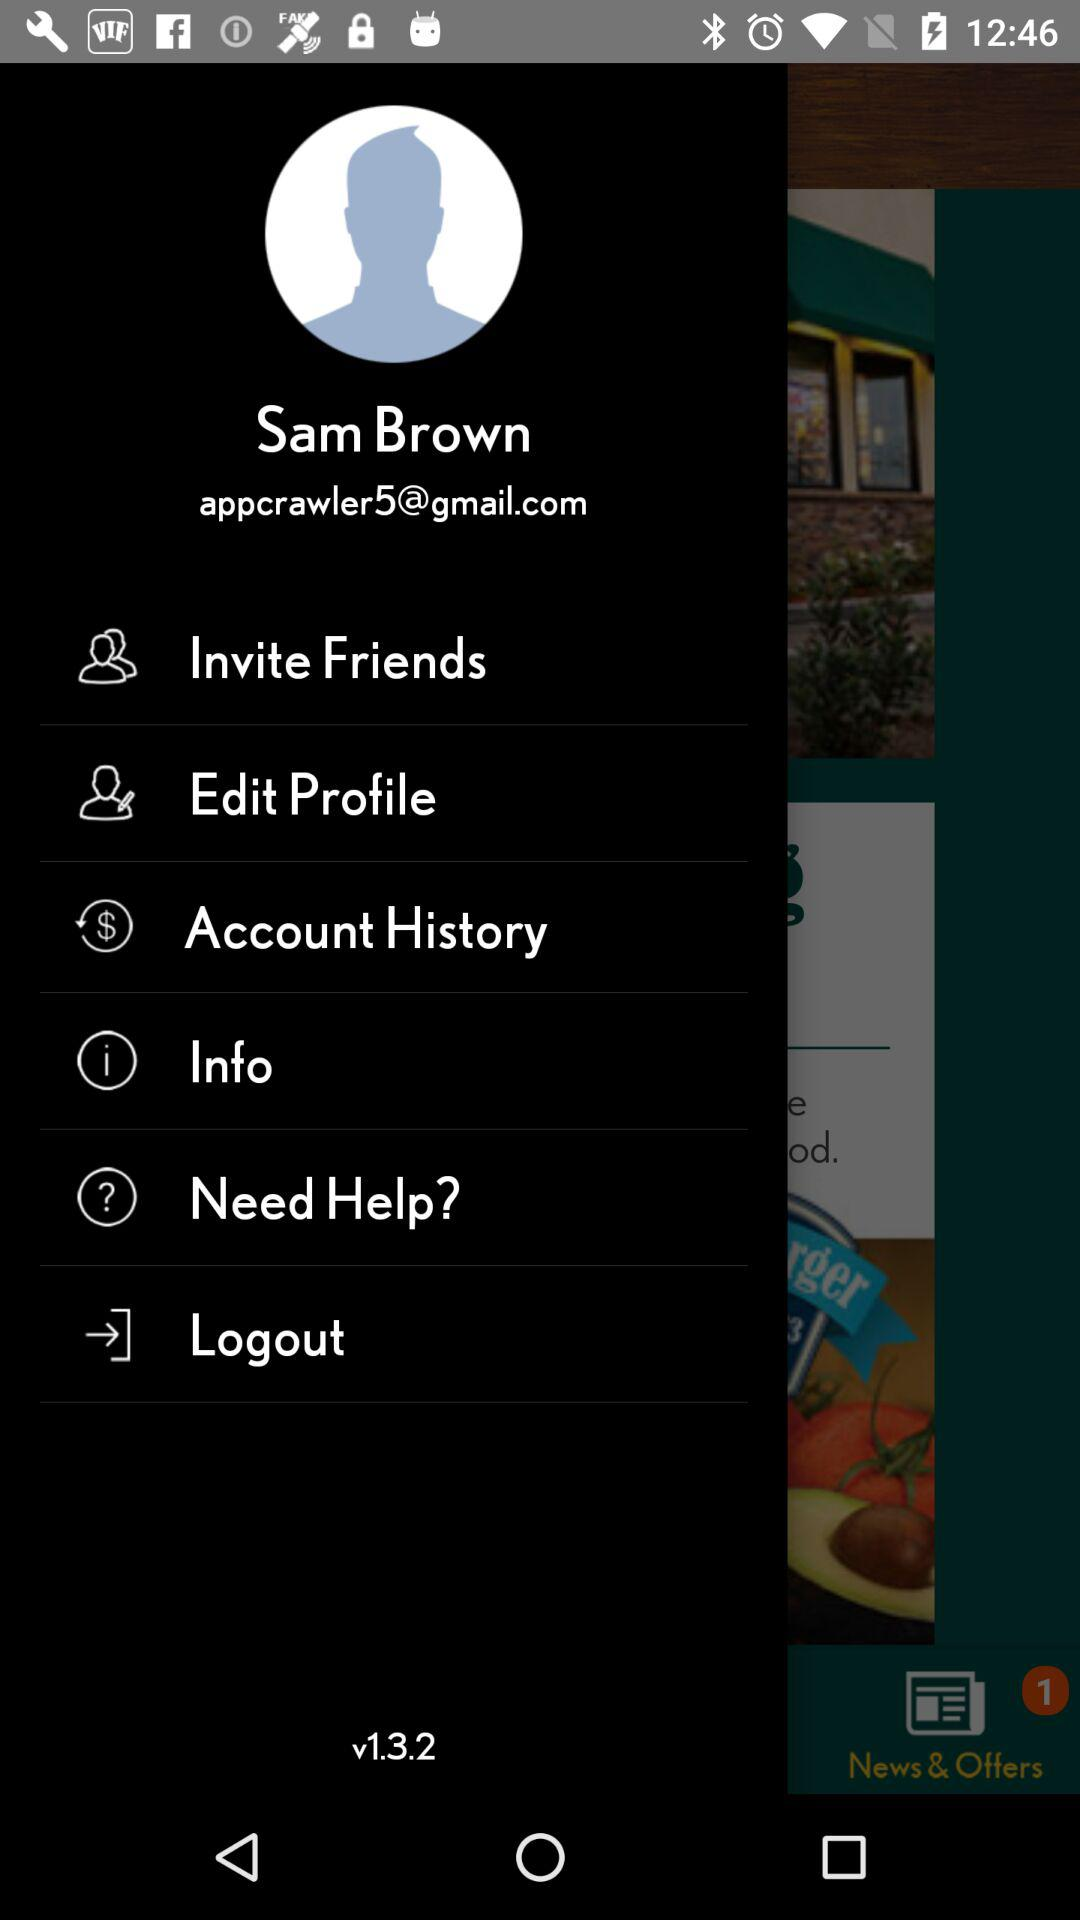What is the email address? The email address is appcrawler5@gmail.com. 